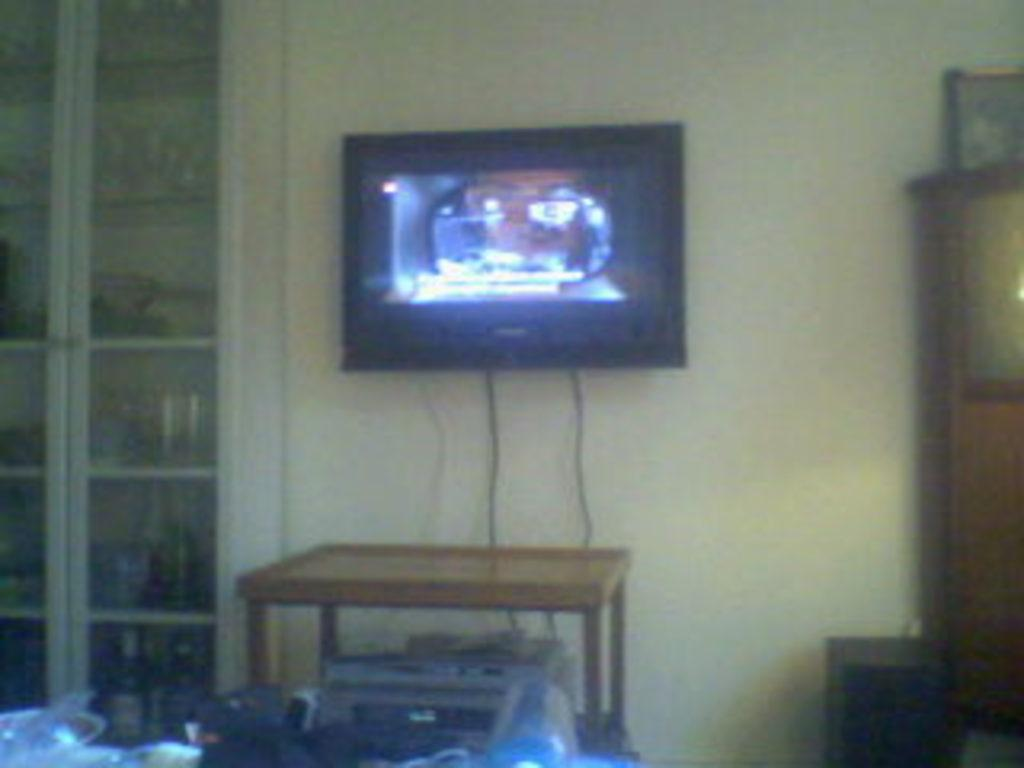What is the main object in the center of the image? There is a monitor in the center of the image. What piece of furniture is present in the image? There is a table, a stool, and a cupboard in the image. Can you describe the background of the image? There is a wall in the background of the image, along with a photo frame and a shelf. What other objects can be seen in the image? There are a few other objects in the image, but their specific details are not mentioned in the provided facts. What type of books does the guide recommend for camping in the image? There are no books, guide, or camping-related items present in the image. 